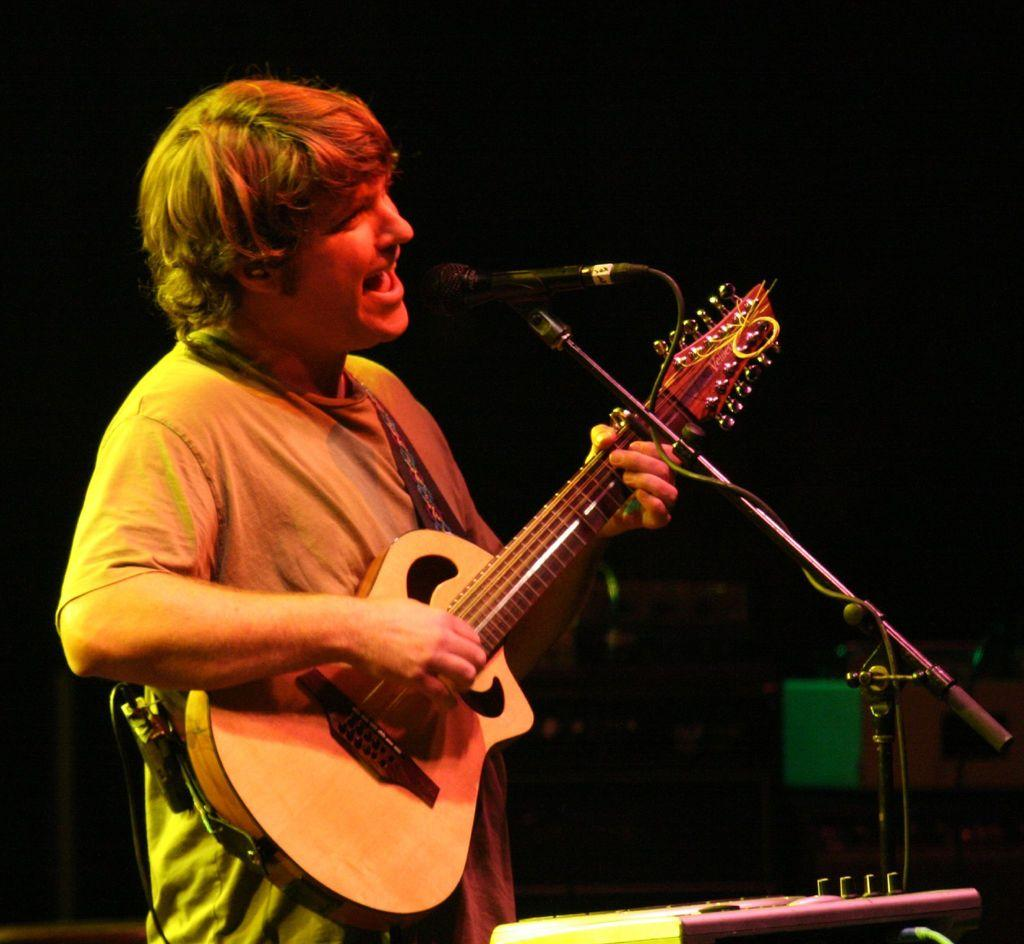What is the person in the image doing? The person in the image is playing a guitar and singing. What object is the person using to amplify their voice? There is a microphone in the image. What type of rod is the person using to play the guitar in the image? There is no rod mentioned or visible in the image; the person is using their hands to play the guitar. 